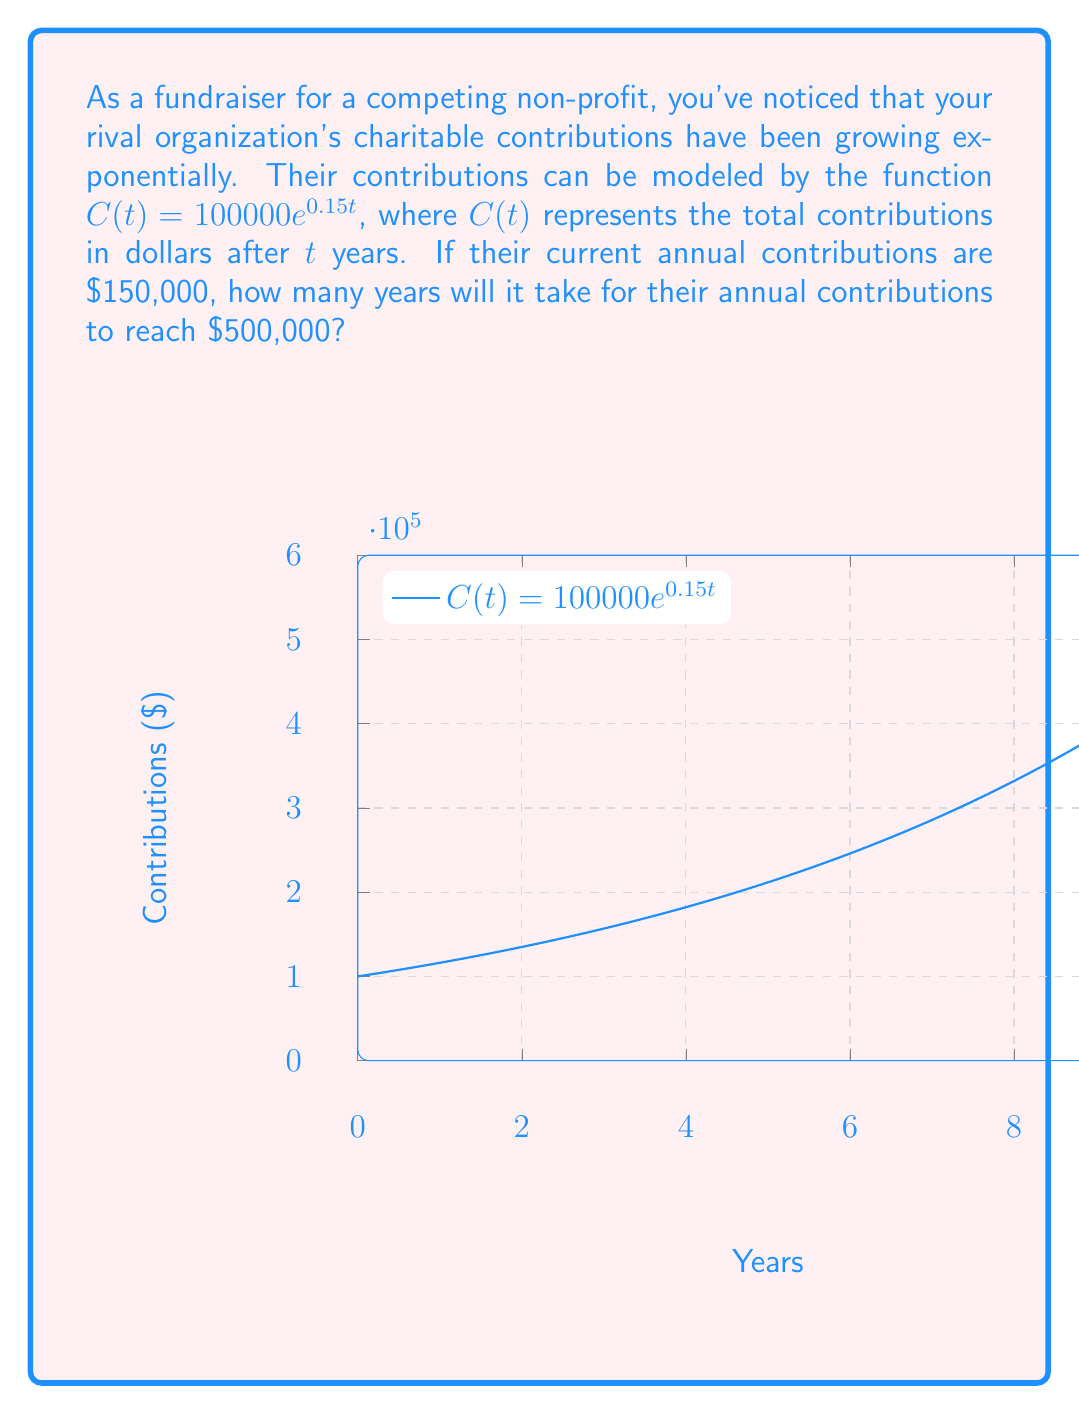Solve this math problem. Let's approach this step-by-step:

1) We're given the function $C(t) = 100000e^{0.15t}$, where $C(t)$ is in dollars and $t$ is in years.

2) We need to find $t$ when $C(t) = 500000$. So, we set up the equation:

   $500000 = 100000e^{0.15t}$

3) Divide both sides by 100000:

   $5 = e^{0.15t}$

4) Take the natural logarithm of both sides:

   $\ln(5) = \ln(e^{0.15t})$

5) Using the property of logarithms, $\ln(e^x) = x$, we get:

   $\ln(5) = 0.15t$

6) Solve for $t$:

   $t = \frac{\ln(5)}{0.15}$

7) Use a calculator to evaluate:

   $t \approx 10.75$ years

Therefore, it will take approximately 10.75 years for the annual contributions to reach $500,000.
Answer: $\frac{\ln(5)}{0.15} \approx 10.75$ years 